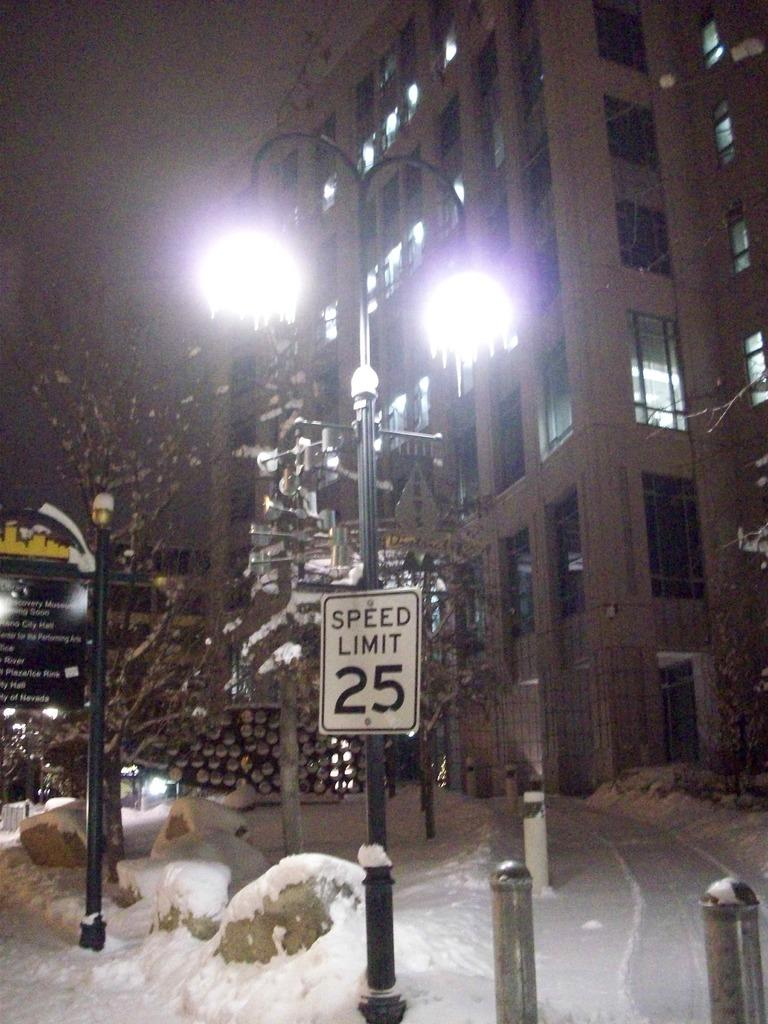What structures can be seen in the image? There are poles, sign boards, buildings, and trees in the image. What materials are used for the structures in the image? The poles and metal rods are made of metal, while the sign boards and buildings are likely made of other materials. What is the weather like in the image? There is snow visible in the image, indicating a cold or wintry environment. What type of scarf is being sold at the lowest price in the image? There is no indication of a scarf or any pricing information in the image. What rule is being enforced by the sign boards in the image? The sign boards in the image do not specify any rules or regulations; they are likely displaying advertisements or information. 